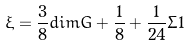<formula> <loc_0><loc_0><loc_500><loc_500>\xi = \frac { 3 } { 8 } d i m G + \frac { 1 } { 8 } + \frac { 1 } { 2 4 } \Sigma 1</formula> 